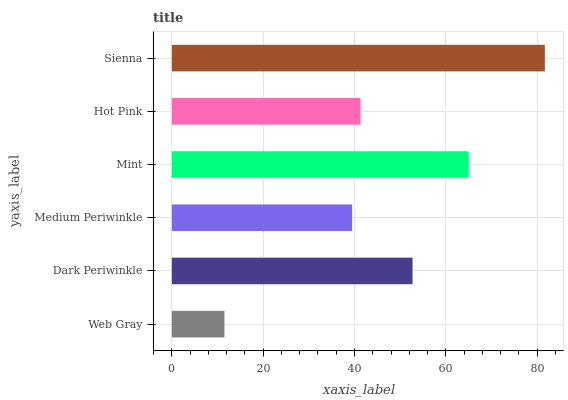Is Web Gray the minimum?
Answer yes or no. Yes. Is Sienna the maximum?
Answer yes or no. Yes. Is Dark Periwinkle the minimum?
Answer yes or no. No. Is Dark Periwinkle the maximum?
Answer yes or no. No. Is Dark Periwinkle greater than Web Gray?
Answer yes or no. Yes. Is Web Gray less than Dark Periwinkle?
Answer yes or no. Yes. Is Web Gray greater than Dark Periwinkle?
Answer yes or no. No. Is Dark Periwinkle less than Web Gray?
Answer yes or no. No. Is Dark Periwinkle the high median?
Answer yes or no. Yes. Is Hot Pink the low median?
Answer yes or no. Yes. Is Hot Pink the high median?
Answer yes or no. No. Is Web Gray the low median?
Answer yes or no. No. 